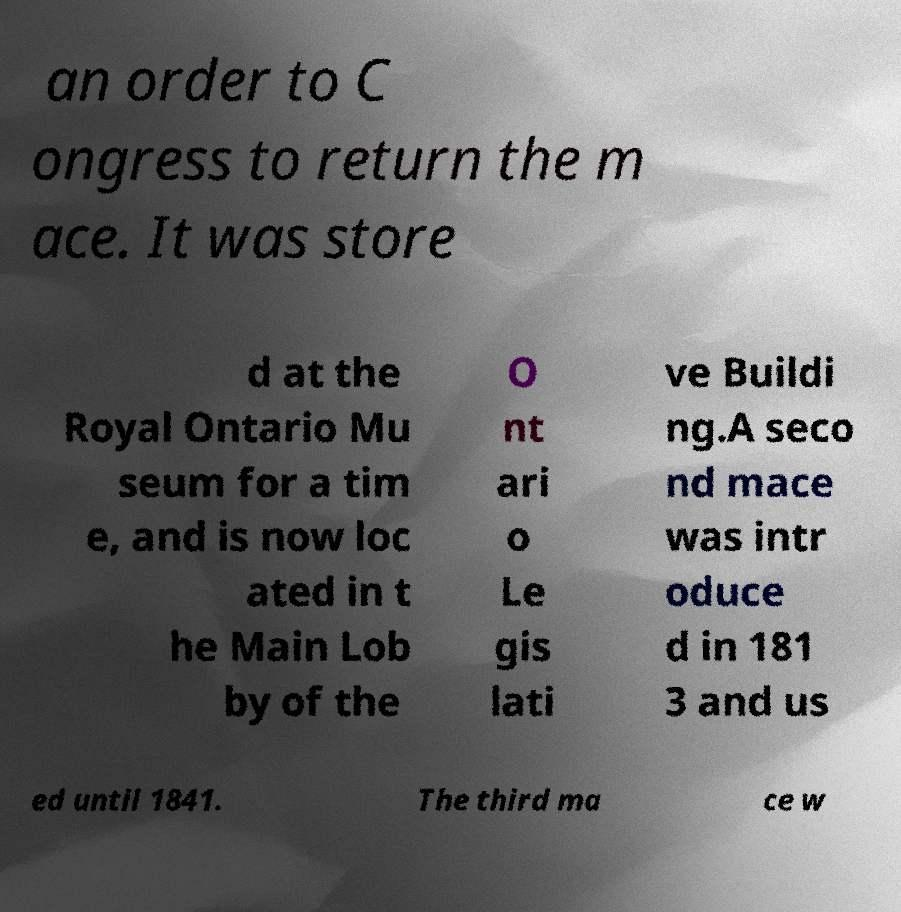Can you accurately transcribe the text from the provided image for me? an order to C ongress to return the m ace. It was store d at the Royal Ontario Mu seum for a tim e, and is now loc ated in t he Main Lob by of the O nt ari o Le gis lati ve Buildi ng.A seco nd mace was intr oduce d in 181 3 and us ed until 1841. The third ma ce w 